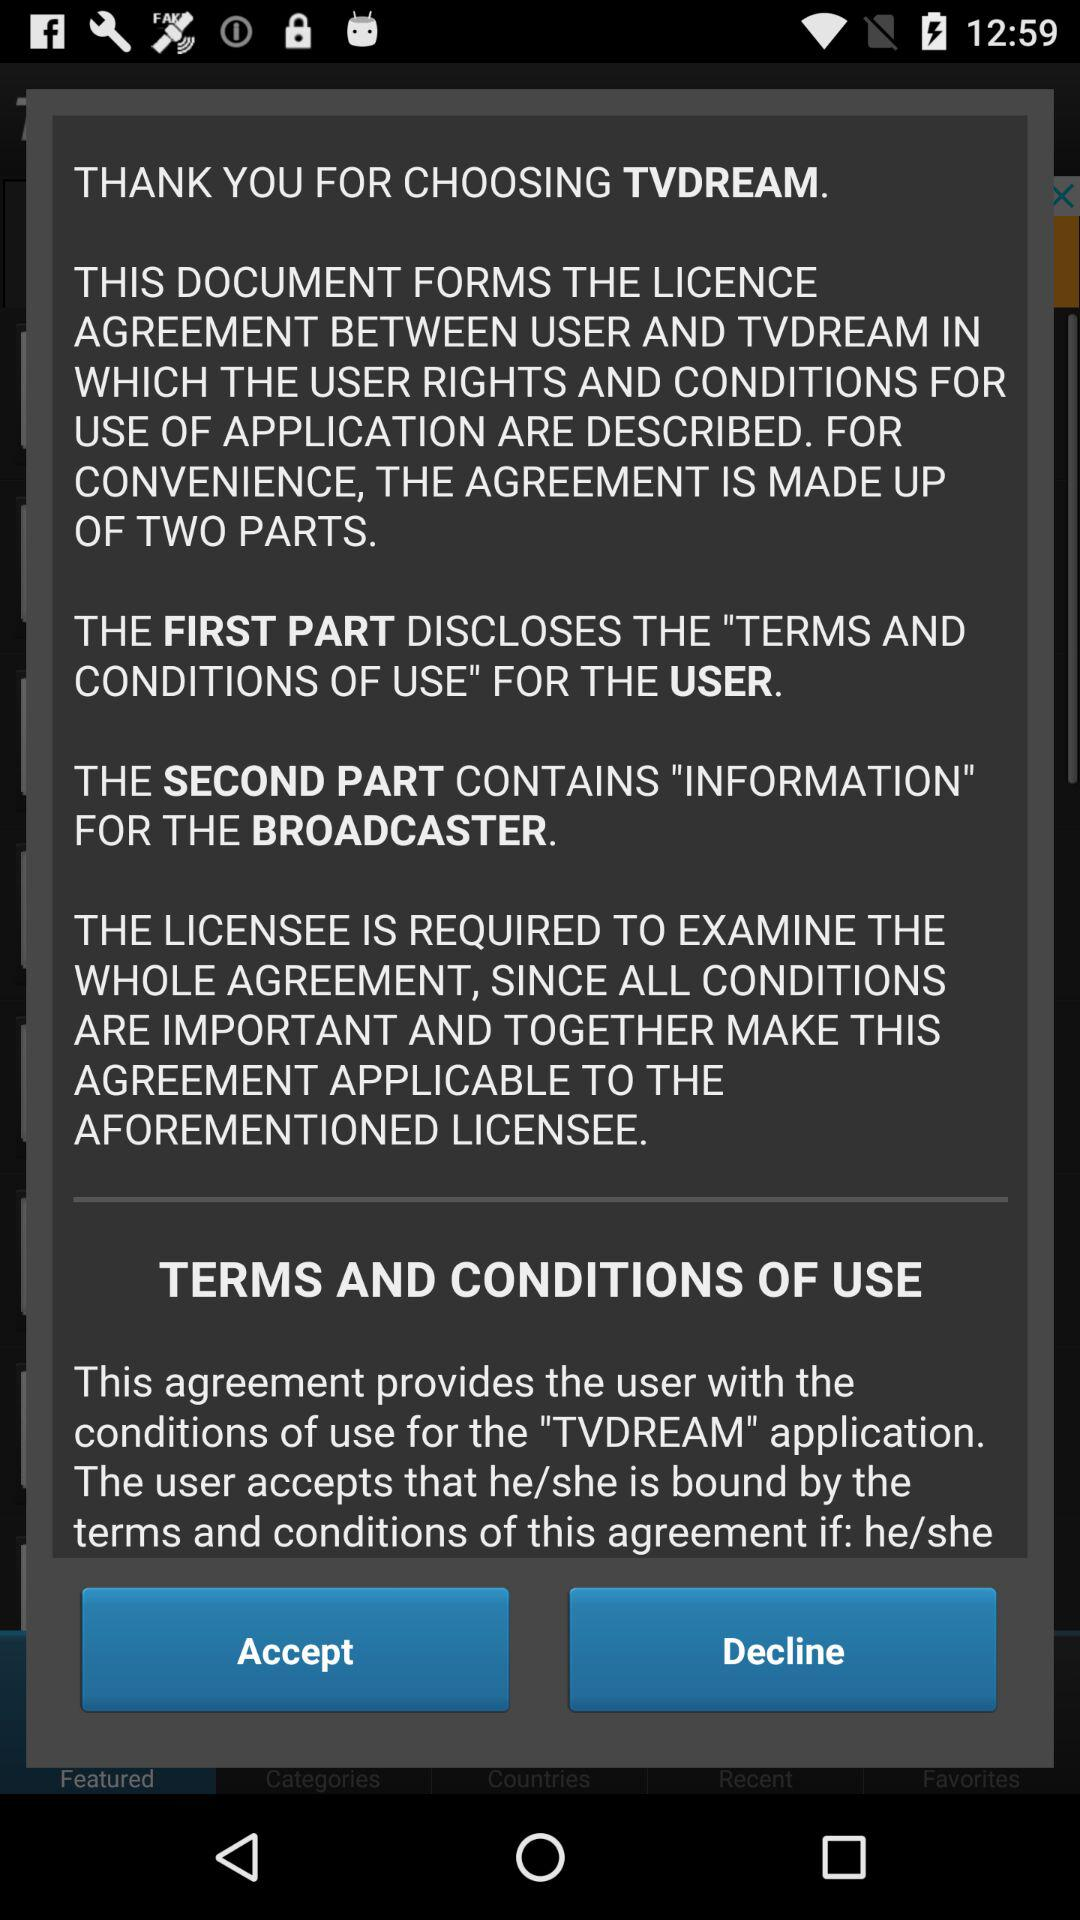What is the application name? The application name is "TVDREAM". 